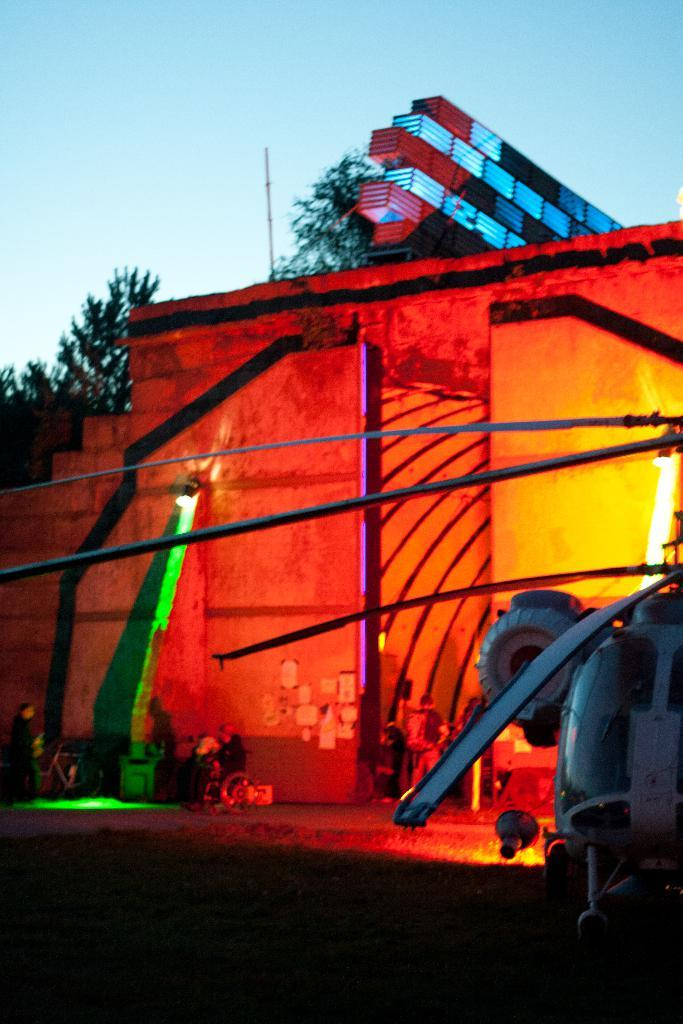What is the main subject of the image? The main subject of the image is a helicopter. What can be seen in the background of the image? In the background of the image, there is a wall, people, objects, and trees. What is visible at the top of the image? The sky is visible at the top of the image. How many kittens are sitting on the helicopter's legs in the image? There are no kittens or legs of the helicopter visible in the image. What color is the kitten's throat in the image? There is no kitten present in the image, so its throat color cannot be determined. 